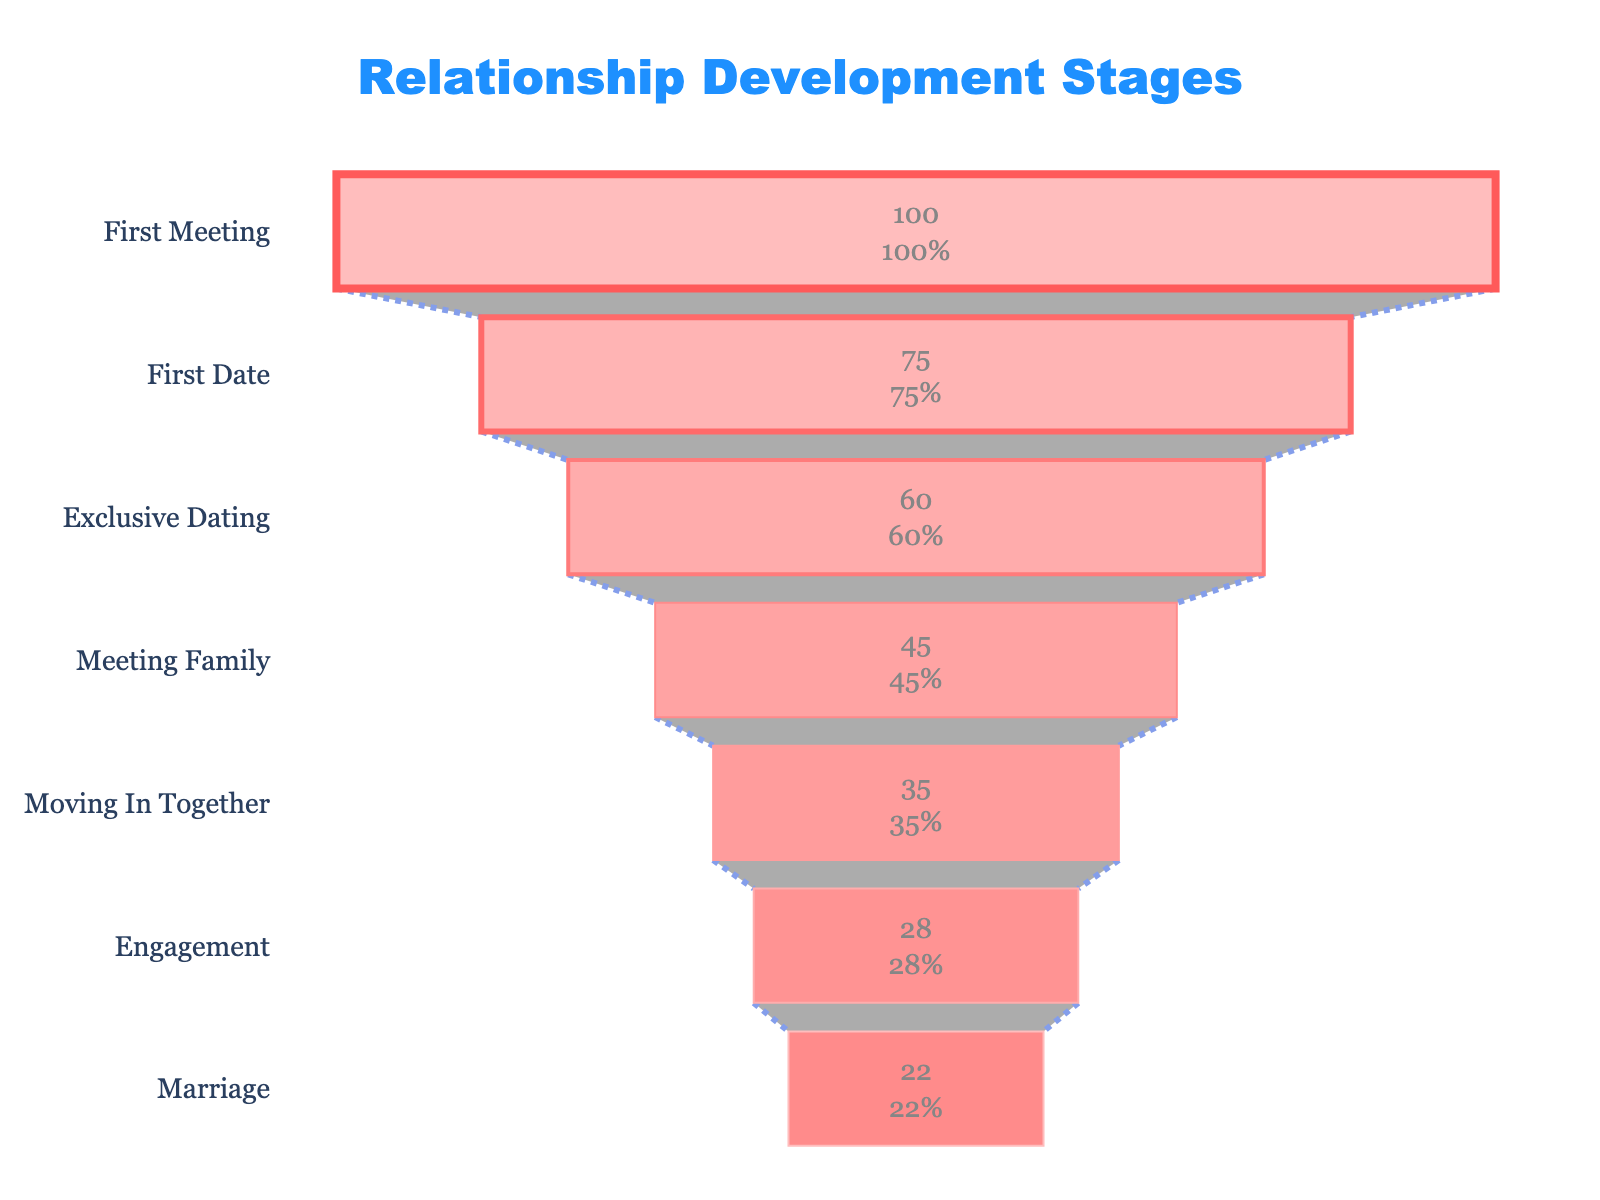What is the title of the chart? The title is displayed prominently at the top of the chart. It reads, "Relationship Development Stages."
Answer: Relationship Development Stages Which stage shows the highest percentage value? The highest percentage is represented by the first bar in the funnel chart and corresponds to "First Meeting" with 100%.
Answer: First Meeting What percentage of couples reach the "Engagement" stage? The specific value for "Engagement" is directly visible in the chart. It shows 28%.
Answer: 28% What is the difference in percentage between "First Date" and "Meeting Family"? To find the difference, subtract the percentage for "Meeting Family" (45%) from the percentage for "First Date" (75%).
Answer: 30% Which stage has a higher percentage: "Moving In Together" or "Marriage"? By comparing the two stages visually, "Moving In Together" has a higher percentage (35%) than "Marriage" (22%).
Answer: Moving In Together How many stages are represented in the funnel chart? Counting each stage listed on the y-axis provides the total number of stages. There are 7 stages.
Answer: 7 What is the percentage decrease from the "Exclusive Dating" stage to the "Moving In Together" stage? Subtract the percentage of "Moving In Together" (35%) from "Exclusive Dating" (60%) to find the decrease.
Answer: 25% What is the chronological order of stages where the percentage drops below 50%? Identify stages with percentages below 50% and list them in chronological order: "Meeting Family," "Moving In Together," "Engagement," "Marriage."
Answer: Meeting Family, Moving In Together, Engagement, Marriage By how much does the percentage decrease from "Moving In Together" to "Marriage"? Subtract the percentage of "Marriage" (22%) from "Moving In Together" (35%) to find the decrease.
Answer: 13% What percentage of couples reaches both "First Date" and "Exclusive Dating" stages? Both stages must be referenced from the chart. The percentages are 75% for "First Date" and 60% for "Exclusive Dating."
Answer: 60% 